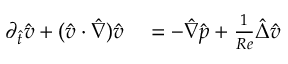Convert formula to latex. <formula><loc_0><loc_0><loc_500><loc_500>\begin{array} { r l } { \partial _ { \hat { t } } \hat { v } + ( \hat { v } \cdot \hat { \nabla } ) \hat { v } } & = - \hat { \nabla } \hat { p } + \frac { 1 } { R e } \hat { \Delta } \hat { v } } \end{array}</formula> 